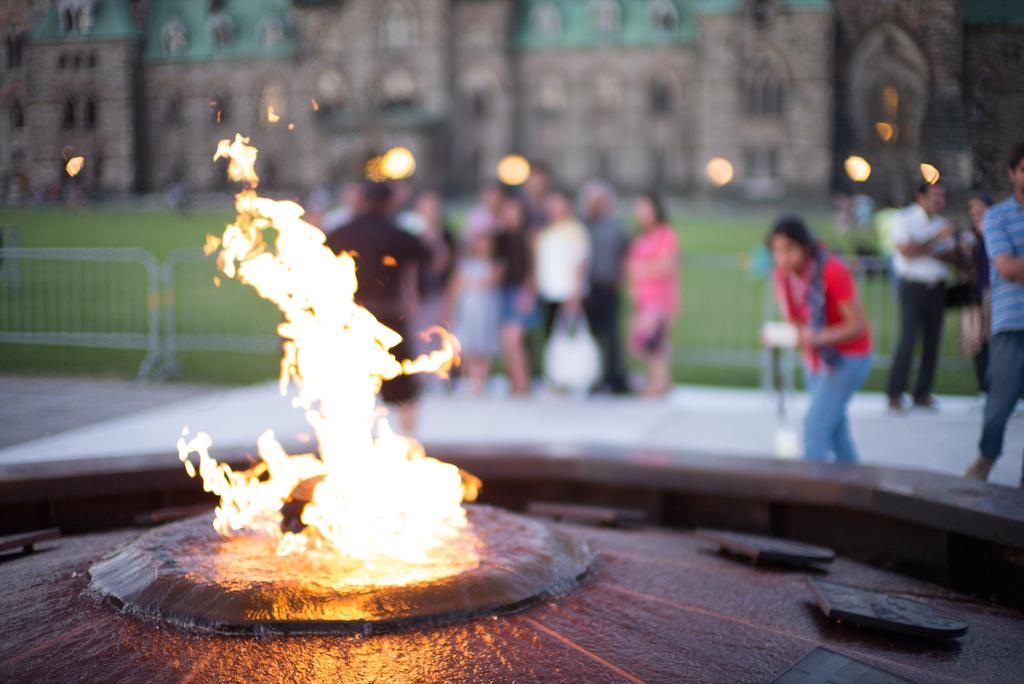What is the main element in the image? There is fire in the image. What can be seen in the background of the image? There are people standing and buildings visible in the background. What is the color of the grass in the image? The grass is green in color. What else can be seen in the image besides the fire and grass? There are lights visible in the image. What type of dress is the fire wearing in the image? The fire is not wearing a dress, as it is a natural element and not a person. 